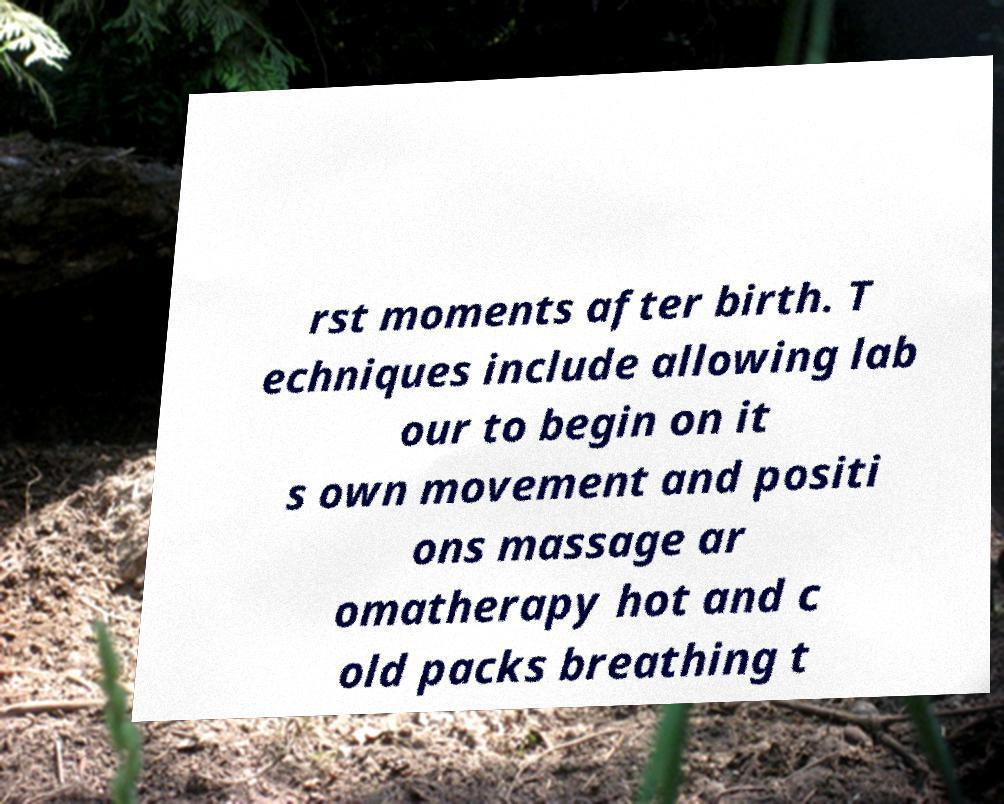Can you read and provide the text displayed in the image?This photo seems to have some interesting text. Can you extract and type it out for me? rst moments after birth. T echniques include allowing lab our to begin on it s own movement and positi ons massage ar omatherapy hot and c old packs breathing t 